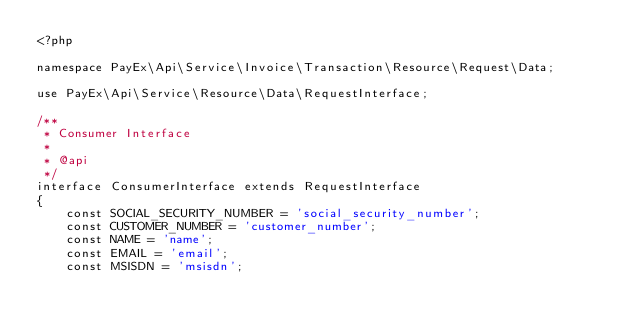Convert code to text. <code><loc_0><loc_0><loc_500><loc_500><_PHP_><?php

namespace PayEx\Api\Service\Invoice\Transaction\Resource\Request\Data;

use PayEx\Api\Service\Resource\Data\RequestInterface;

/**
 * Consumer Interface
 *
 * @api
 */
interface ConsumerInterface extends RequestInterface
{
    const SOCIAL_SECURITY_NUMBER = 'social_security_number';
    const CUSTOMER_NUMBER = 'customer_number';
    const NAME = 'name';
    const EMAIL = 'email';
    const MSISDN = 'msisdn';</code> 